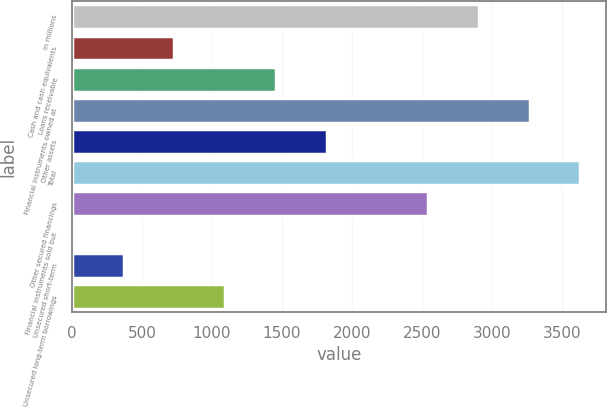<chart> <loc_0><loc_0><loc_500><loc_500><bar_chart><fcel>in millions<fcel>Cash and cash equivalents<fcel>Loans receivable<fcel>Financial instruments owned at<fcel>Other assets<fcel>Total<fcel>Other secured financings<fcel>Financial instruments sold but<fcel>Unsecured short-term<fcel>Unsecured long-term borrowings<nl><fcel>2907<fcel>732<fcel>1457<fcel>3269.5<fcel>1819.5<fcel>3632<fcel>2544.5<fcel>7<fcel>369.5<fcel>1094.5<nl></chart> 